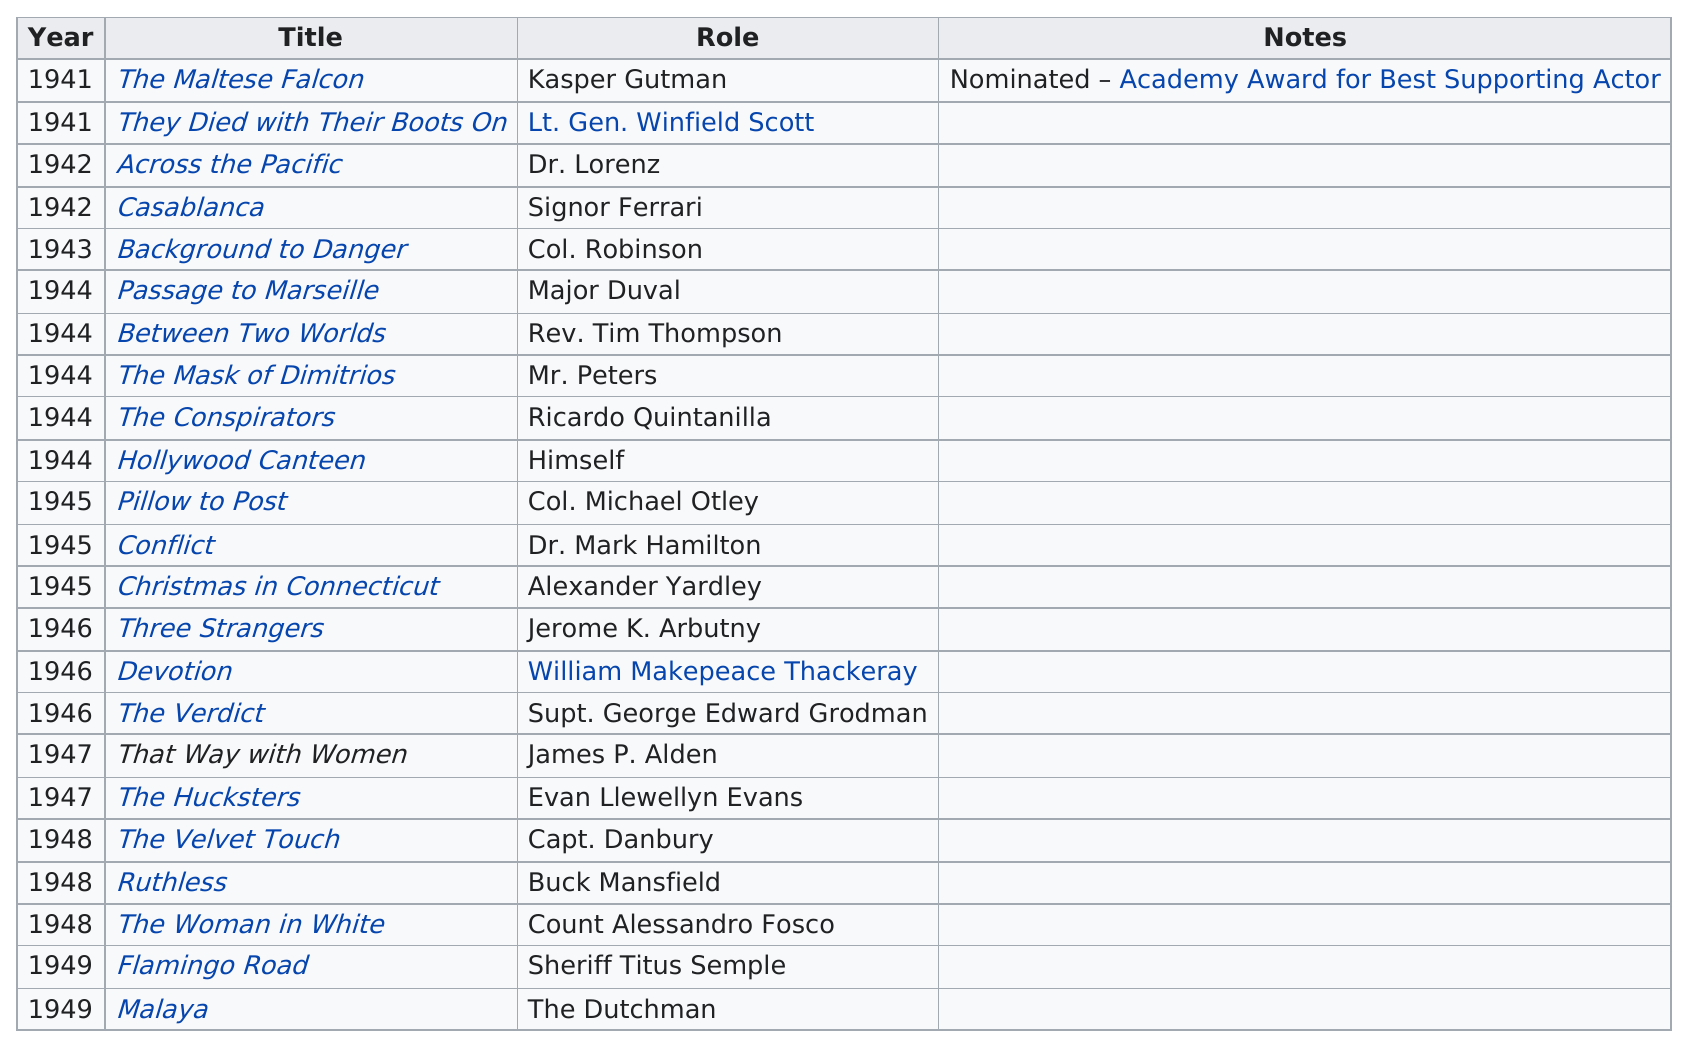List a handful of essential elements in this visual. Greenstreet acted in the movies "Three Strangers," "Devotion," and "The Verdict" in 1946. During the period of 1941-1949, he appeared in 23 movies. In the movie "Hollywood Canteen," he did not play a character and instead played himself. Sydney Greenstreet's acting career lasted for a total of 9 years. The person was nominated for an Oscar for a particular movie called "The Maltese Falcon. 